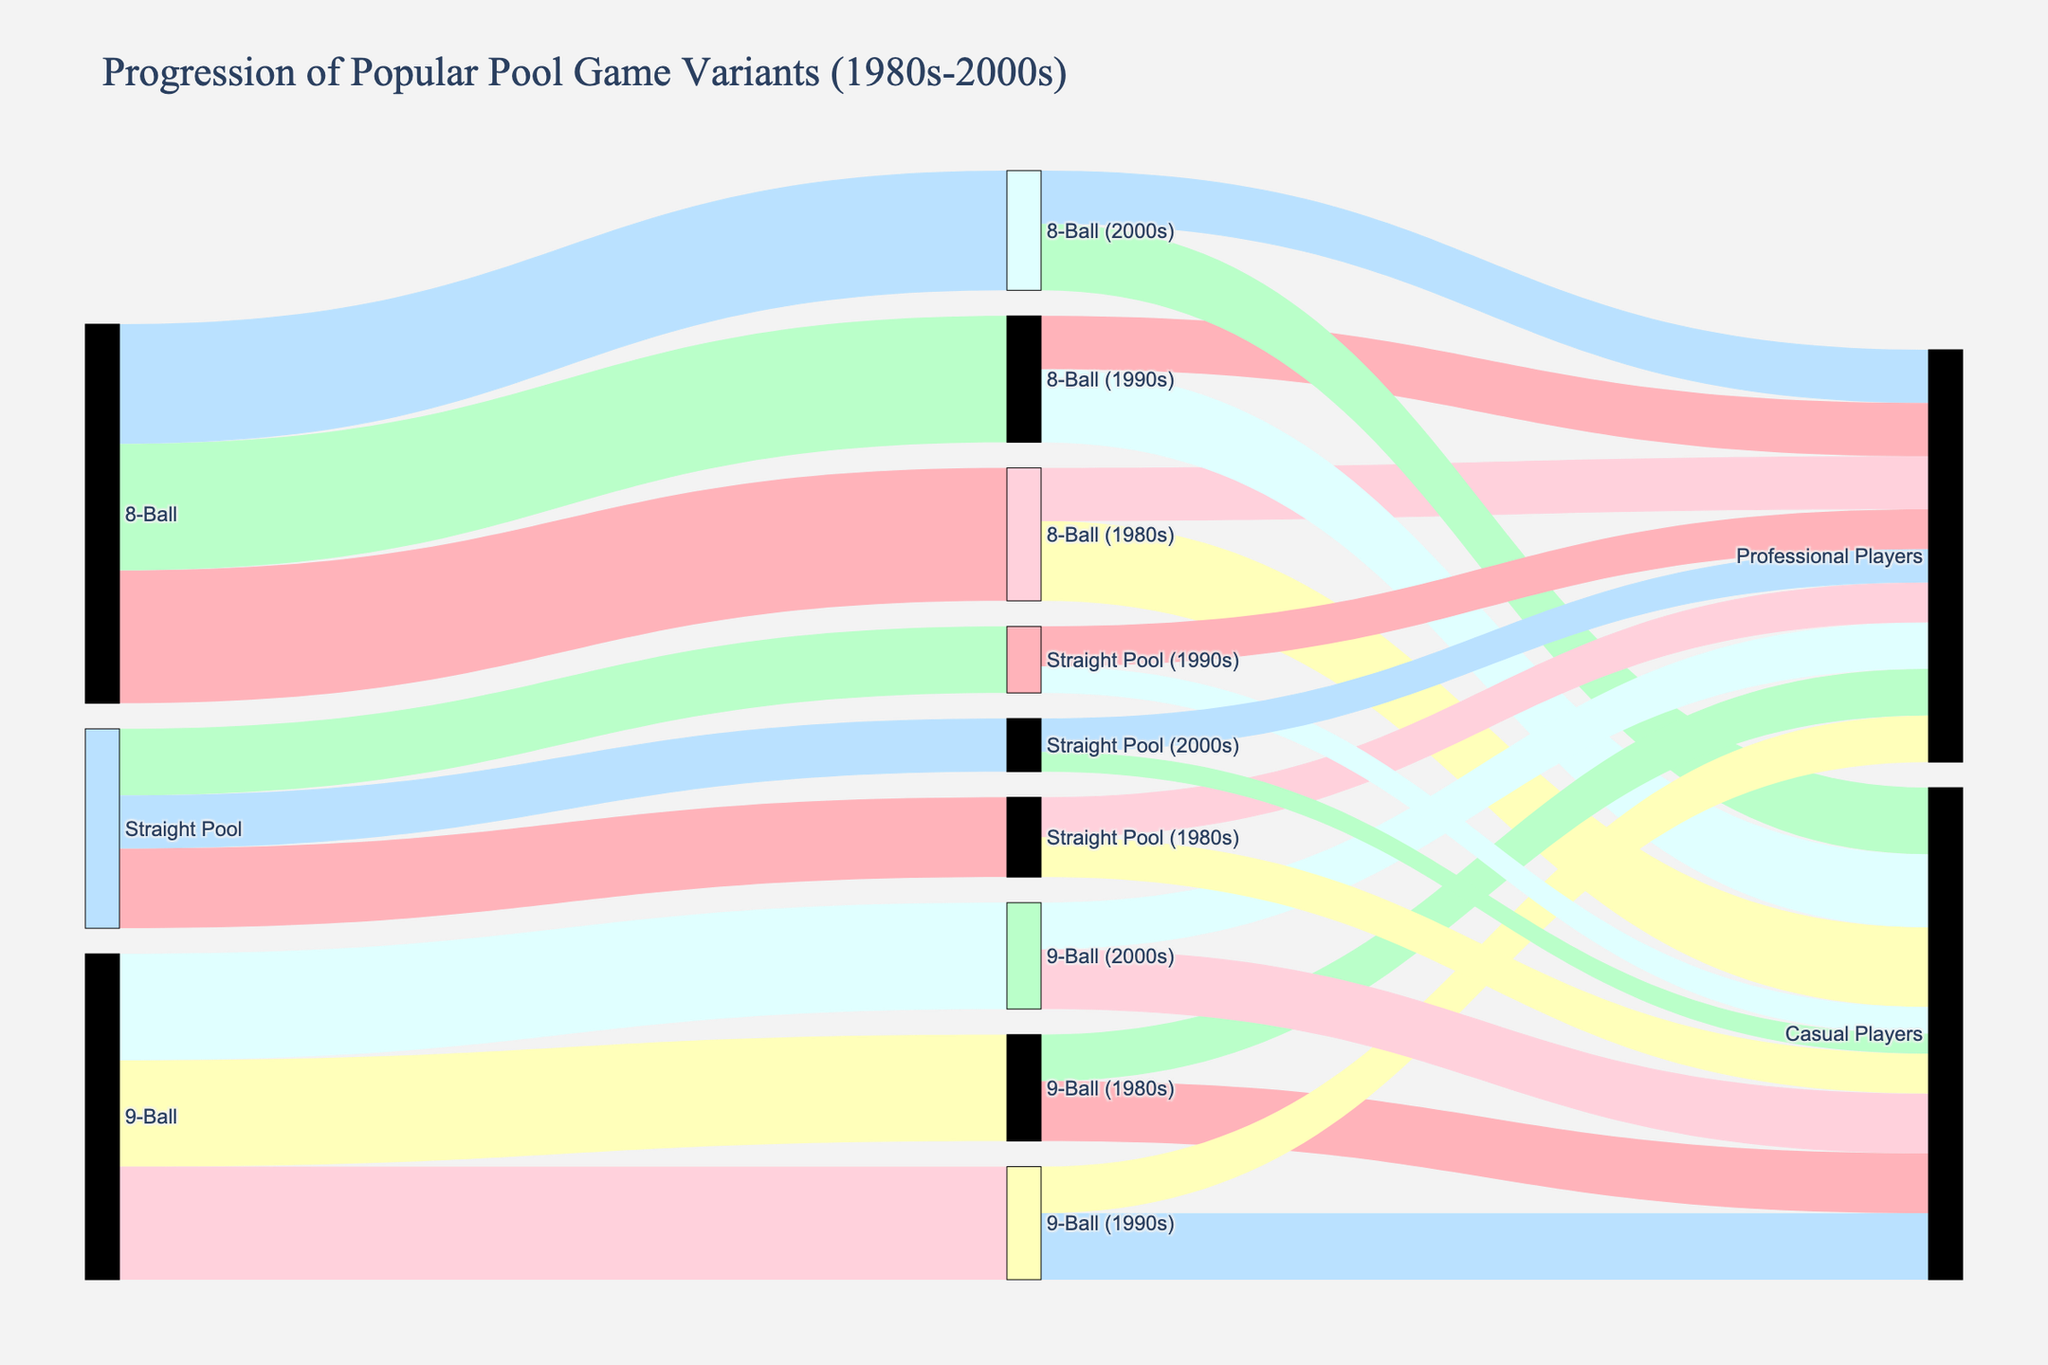Which pool game variant had the highest number of players in the 1980s? To answer this, look at the sources connecting to pool game variants in the 1980s. 8-Ball had 1000 players, 9-Ball had 800 players, and Straight Pool had 600 players. Therefore, 8-Ball had the highest number of players in the 1980s.
Answer: 8-Ball How did the number of professional players for 9-Ball change from the 1980s to the 2000s? Check the links from 9-Ball in the 1980s, 1990s, and 2000s to professional players. The values for professional players are consistent at 350 in all decades.
Answer: No change Which decade saw the largest drop in total players for Straight Pool? Compare the total players in each decade: 600 in the 1980s, 500 in the 1990s, and 400 in the 2000s. The largest drop is from 600 to 500, a decrease of 100.
Answer: 1980s to 1990s Which pool variant had the most persistent number of professional players over the decades? Examine the values of professional players across decades for each variant. Professional players in 8-Ball, 9-Ball, and Straight Pool remained stable. All values for 8-Ball, 9-Ball, and Straight Pool for professional players are consistent.
Answer: All are consistent Did any pool game variant have an increase in casual players from the 1980s to the 1990s? Compare the values of casual players from the 1980s to the 1990s for each variant. 9-Ball increased from 450 to 500 casual players.
Answer: 9-Ball What is the total number of players (both casual and professional) for 8-Ball in the 2000s? Add the number of casual players (500) to professional players (400) for 8-Ball in the 2000s. The total is 500 + 400 = 900.
Answer: 900 How did the player base of Straight Pool in the 1980s compare with the 2000s? In the 1980s, Straight Pool had 600 players, while in the 2000s, it had 400 players. This shows a decrease of 200 players.
Answer: Decreased by 200 players Which variant saw its player base remain the most stable over the decades? Compare the total player counts across decades for each variant. 9-Ball has 800 (1980s), 850 (1990s), 800 (2000s), showing the least fluctuation.
Answer: 9-Ball What is the difference in the number of professional players between 8-Ball and Straight Pool in the 2000s? In the 2000s, 8-Ball has 400 professional players, and Straight Pool has 250 professional players. The difference is 400 - 250 = 150.
Answer: 150 Which variant shows a consistent number of professional players through all three decades? Review professional player counts for each variant across decades. 8-Ball and 9-Ball both maintain a constant professional player count.
Answer: 8-Ball, 9-Ball 